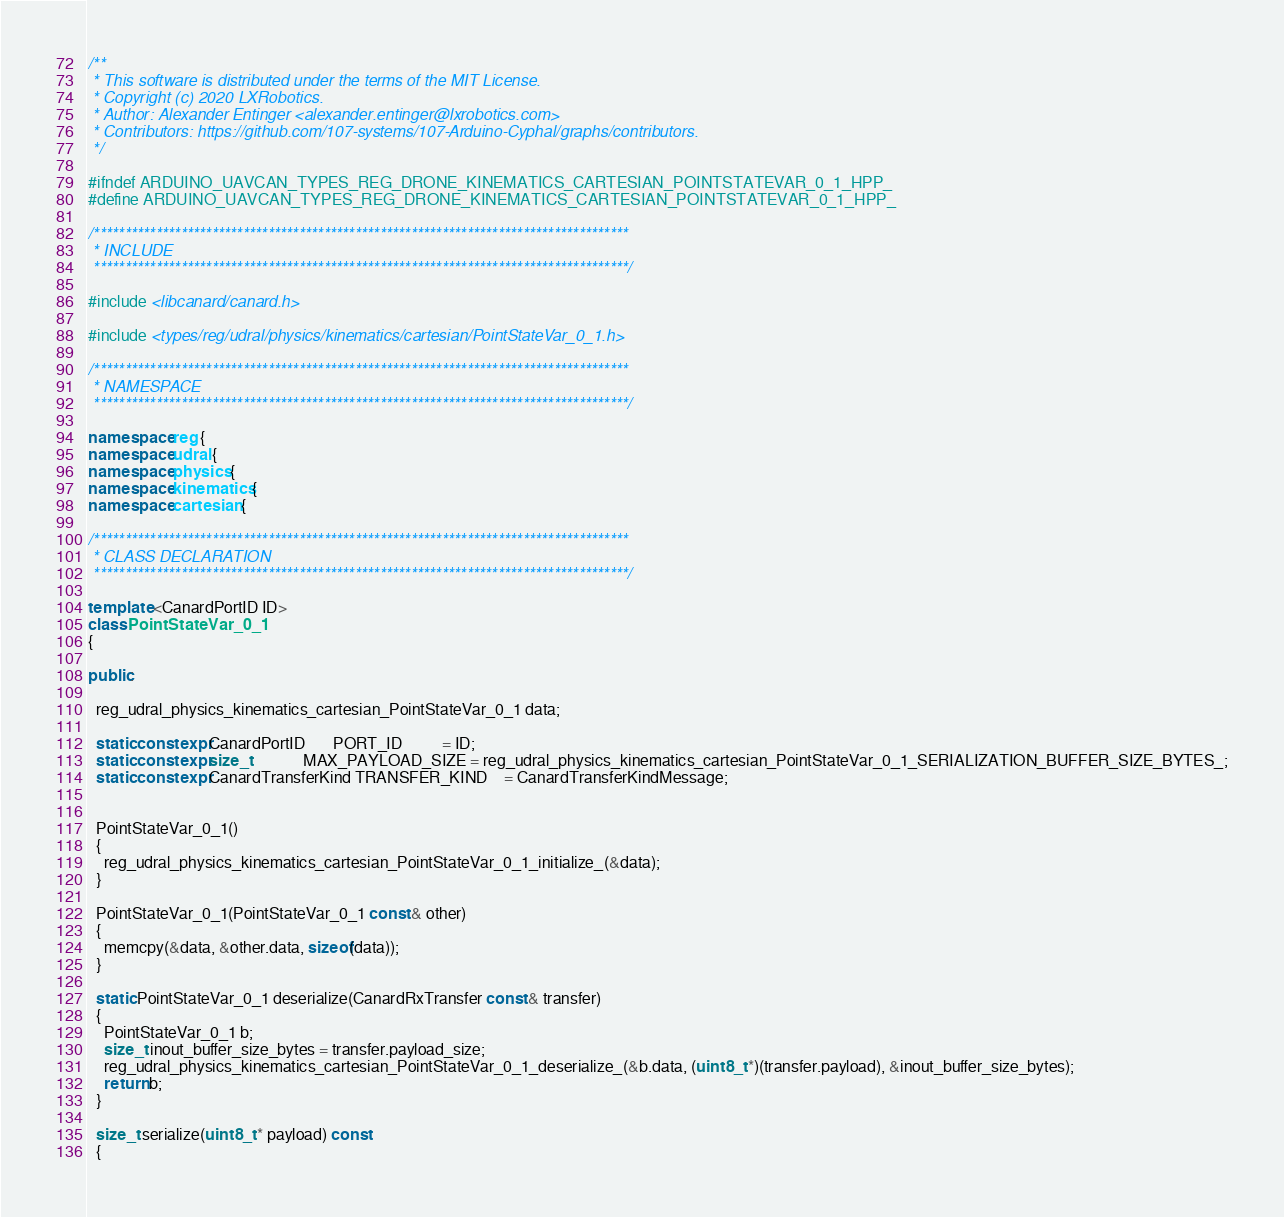Convert code to text. <code><loc_0><loc_0><loc_500><loc_500><_C++_>/**
 * This software is distributed under the terms of the MIT License.
 * Copyright (c) 2020 LXRobotics.
 * Author: Alexander Entinger <alexander.entinger@lxrobotics.com>
 * Contributors: https://github.com/107-systems/107-Arduino-Cyphal/graphs/contributors.
 */

#ifndef ARDUINO_UAVCAN_TYPES_REG_DRONE_KINEMATICS_CARTESIAN_POINTSTATEVAR_0_1_HPP_
#define ARDUINO_UAVCAN_TYPES_REG_DRONE_KINEMATICS_CARTESIAN_POINTSTATEVAR_0_1_HPP_

/**************************************************************************************
 * INCLUDE
 **************************************************************************************/

#include <libcanard/canard.h>

#include <types/reg/udral/physics/kinematics/cartesian/PointStateVar_0_1.h>

/**************************************************************************************
 * NAMESPACE
 **************************************************************************************/

namespace reg {
namespace udral {
namespace physics {
namespace kinematics {
namespace cartesian {

/**************************************************************************************
 * CLASS DECLARATION
 **************************************************************************************/

template <CanardPortID ID>
class PointStateVar_0_1
{

public:

  reg_udral_physics_kinematics_cartesian_PointStateVar_0_1 data;

  static constexpr CanardPortID       PORT_ID          = ID;
  static constexpr size_t             MAX_PAYLOAD_SIZE = reg_udral_physics_kinematics_cartesian_PointStateVar_0_1_SERIALIZATION_BUFFER_SIZE_BYTES_;
  static constexpr CanardTransferKind TRANSFER_KIND    = CanardTransferKindMessage;


  PointStateVar_0_1()
  {
    reg_udral_physics_kinematics_cartesian_PointStateVar_0_1_initialize_(&data);
  }

  PointStateVar_0_1(PointStateVar_0_1 const & other)
  {
    memcpy(&data, &other.data, sizeof(data));
  }

  static PointStateVar_0_1 deserialize(CanardRxTransfer const & transfer)
  {
    PointStateVar_0_1 b;
    size_t inout_buffer_size_bytes = transfer.payload_size;
    reg_udral_physics_kinematics_cartesian_PointStateVar_0_1_deserialize_(&b.data, (uint8_t *)(transfer.payload), &inout_buffer_size_bytes);
    return b;
  }

  size_t serialize(uint8_t * payload) const
  {</code> 